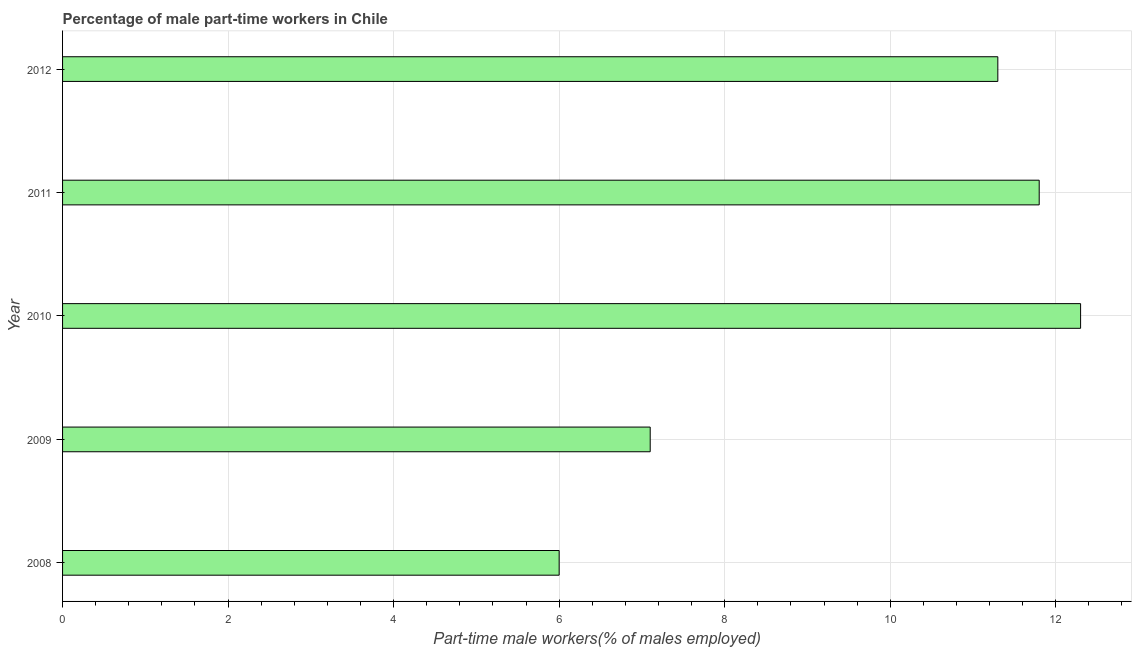Does the graph contain any zero values?
Ensure brevity in your answer.  No. What is the title of the graph?
Your response must be concise. Percentage of male part-time workers in Chile. What is the label or title of the X-axis?
Your answer should be compact. Part-time male workers(% of males employed). What is the label or title of the Y-axis?
Keep it short and to the point. Year. What is the percentage of part-time male workers in 2011?
Provide a short and direct response. 11.8. Across all years, what is the maximum percentage of part-time male workers?
Ensure brevity in your answer.  12.3. In which year was the percentage of part-time male workers minimum?
Your answer should be compact. 2008. What is the sum of the percentage of part-time male workers?
Make the answer very short. 48.5. What is the average percentage of part-time male workers per year?
Keep it short and to the point. 9.7. What is the median percentage of part-time male workers?
Keep it short and to the point. 11.3. Do a majority of the years between 2008 and 2011 (inclusive) have percentage of part-time male workers greater than 2.8 %?
Keep it short and to the point. Yes. What is the ratio of the percentage of part-time male workers in 2010 to that in 2012?
Your answer should be compact. 1.09. Is the difference between the percentage of part-time male workers in 2010 and 2012 greater than the difference between any two years?
Your answer should be compact. No. What is the difference between the highest and the lowest percentage of part-time male workers?
Provide a succinct answer. 6.3. In how many years, is the percentage of part-time male workers greater than the average percentage of part-time male workers taken over all years?
Provide a succinct answer. 3. Are the values on the major ticks of X-axis written in scientific E-notation?
Make the answer very short. No. What is the Part-time male workers(% of males employed) in 2008?
Keep it short and to the point. 6. What is the Part-time male workers(% of males employed) in 2009?
Provide a succinct answer. 7.1. What is the Part-time male workers(% of males employed) of 2010?
Provide a succinct answer. 12.3. What is the Part-time male workers(% of males employed) of 2011?
Provide a succinct answer. 11.8. What is the Part-time male workers(% of males employed) of 2012?
Your answer should be compact. 11.3. What is the difference between the Part-time male workers(% of males employed) in 2008 and 2012?
Your answer should be very brief. -5.3. What is the difference between the Part-time male workers(% of males employed) in 2009 and 2010?
Make the answer very short. -5.2. What is the difference between the Part-time male workers(% of males employed) in 2009 and 2011?
Ensure brevity in your answer.  -4.7. What is the difference between the Part-time male workers(% of males employed) in 2009 and 2012?
Provide a short and direct response. -4.2. What is the ratio of the Part-time male workers(% of males employed) in 2008 to that in 2009?
Offer a terse response. 0.84. What is the ratio of the Part-time male workers(% of males employed) in 2008 to that in 2010?
Provide a short and direct response. 0.49. What is the ratio of the Part-time male workers(% of males employed) in 2008 to that in 2011?
Your answer should be very brief. 0.51. What is the ratio of the Part-time male workers(% of males employed) in 2008 to that in 2012?
Offer a terse response. 0.53. What is the ratio of the Part-time male workers(% of males employed) in 2009 to that in 2010?
Your answer should be compact. 0.58. What is the ratio of the Part-time male workers(% of males employed) in 2009 to that in 2011?
Ensure brevity in your answer.  0.6. What is the ratio of the Part-time male workers(% of males employed) in 2009 to that in 2012?
Offer a terse response. 0.63. What is the ratio of the Part-time male workers(% of males employed) in 2010 to that in 2011?
Your answer should be compact. 1.04. What is the ratio of the Part-time male workers(% of males employed) in 2010 to that in 2012?
Provide a succinct answer. 1.09. What is the ratio of the Part-time male workers(% of males employed) in 2011 to that in 2012?
Your answer should be compact. 1.04. 